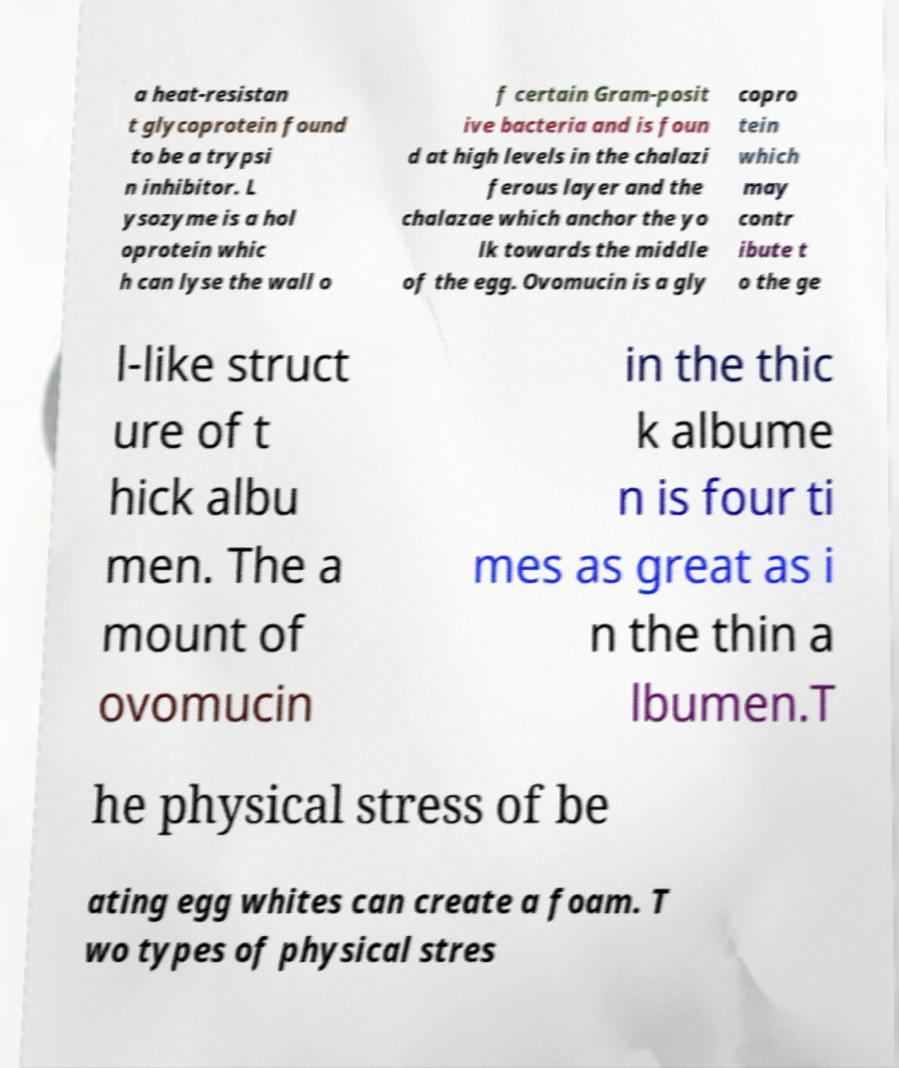Can you accurately transcribe the text from the provided image for me? a heat-resistan t glycoprotein found to be a trypsi n inhibitor. L ysozyme is a hol oprotein whic h can lyse the wall o f certain Gram-posit ive bacteria and is foun d at high levels in the chalazi ferous layer and the chalazae which anchor the yo lk towards the middle of the egg. Ovomucin is a gly copro tein which may contr ibute t o the ge l-like struct ure of t hick albu men. The a mount of ovomucin in the thic k albume n is four ti mes as great as i n the thin a lbumen.T he physical stress of be ating egg whites can create a foam. T wo types of physical stres 